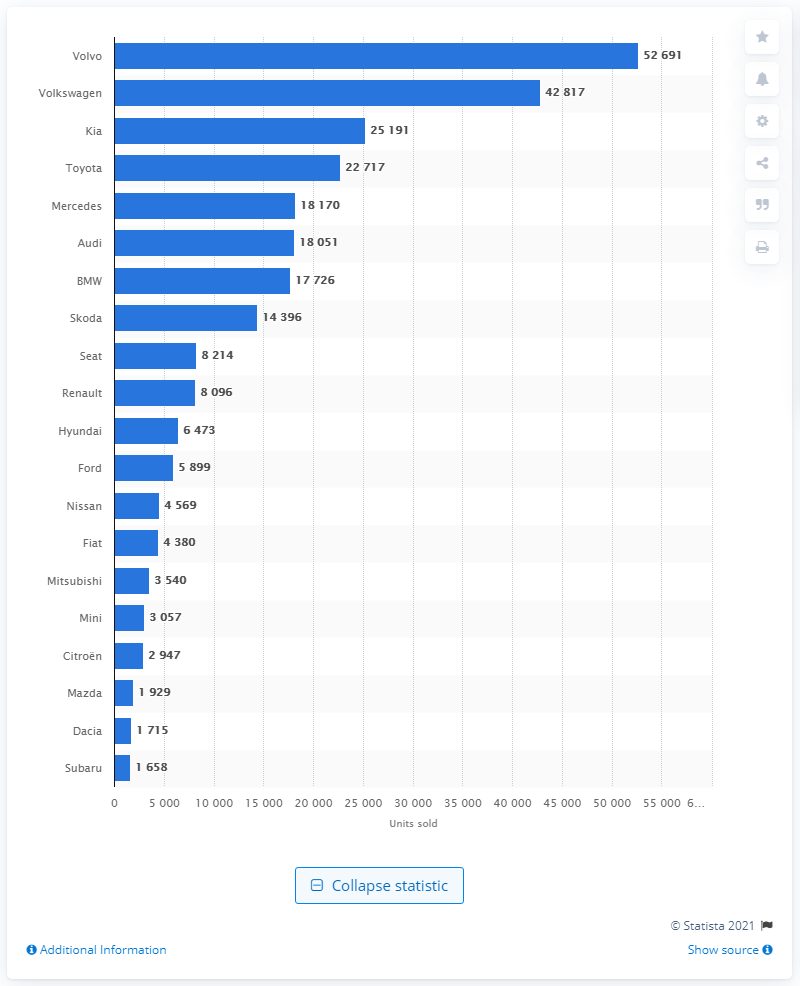Mention a couple of crucial points in this snapshot. The car brand Volkswagen experienced a significant decline in sales demand from 2019 to 2020. The most popular car brand in Sweden in 2020 was Volvo. 